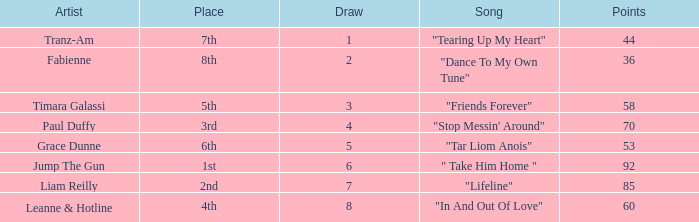What's the highest draw with over 60 points for paul duffy? 4.0. 